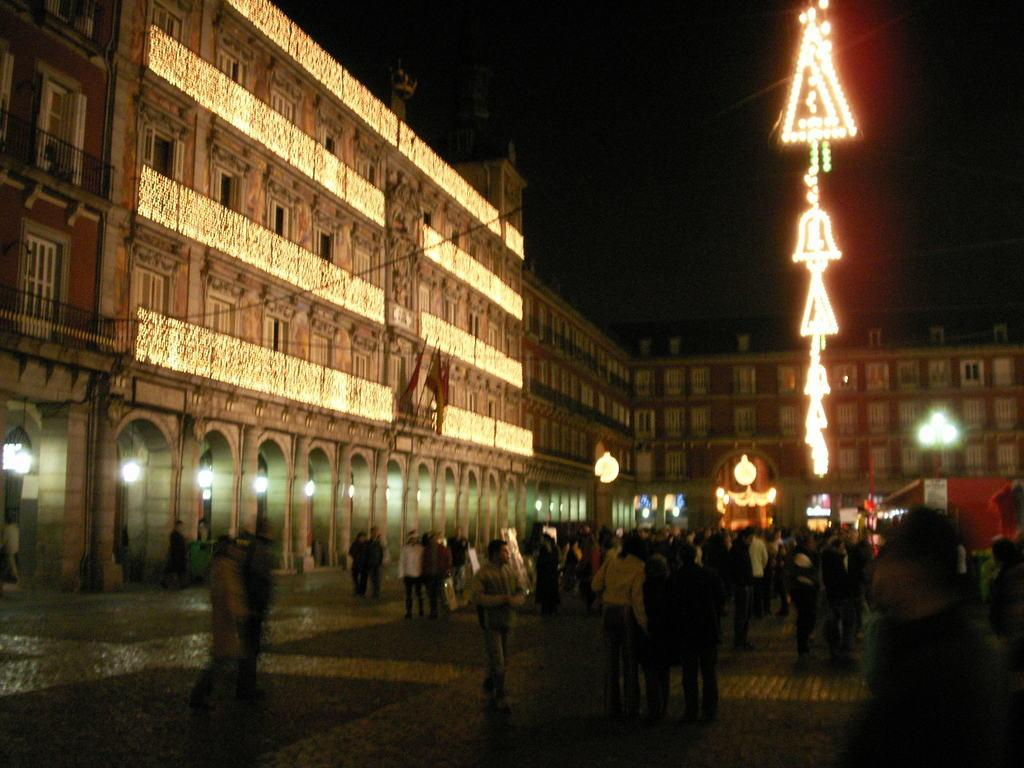What is the primary surface visible in the image? There is a floor in the image. What are the people in the image doing? There are people walking in the image. What structure is located on the left side of the image? There is a building on the left side of the image. What can be seen providing illumination in the image? There are lights visible in the image. What type of paper is being used to cover the cemetery in the image? There is no cemetery or paper present in the image. 